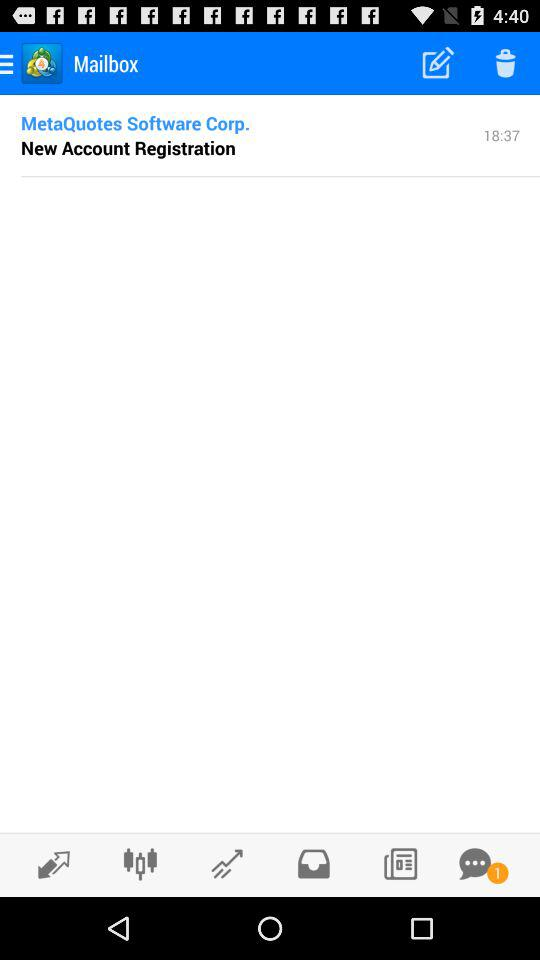What is the name of the application? The name of the application is "Mailbox". 